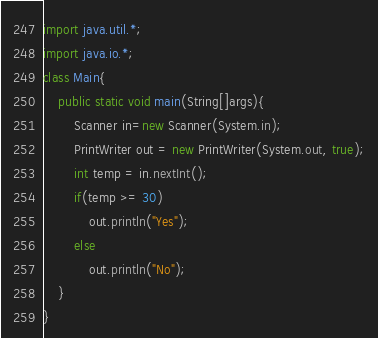<code> <loc_0><loc_0><loc_500><loc_500><_Java_>import java.util.*;
import java.io.*;
class Main{
	public static void main(String[]args){
		Scanner in=new Scanner(System.in);
		PrintWriter out = new PrintWriter(System.out, true);
		int temp = in.nextInt();
		if(temp >= 30)
			out.println("Yes");
		else
			out.println("No");
	}
}
</code> 